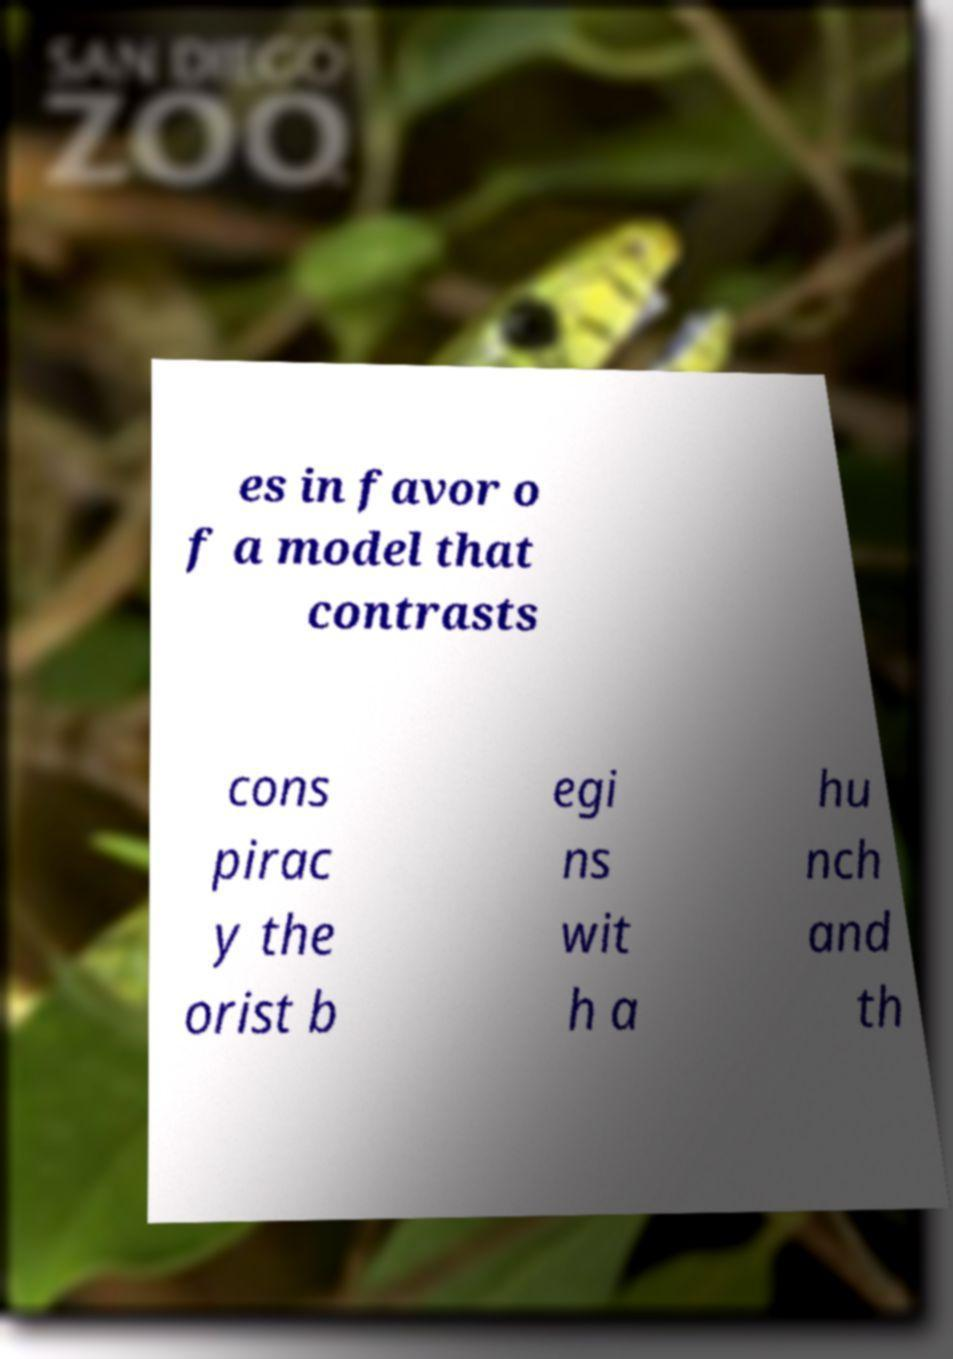I need the written content from this picture converted into text. Can you do that? es in favor o f a model that contrasts cons pirac y the orist b egi ns wit h a hu nch and th 